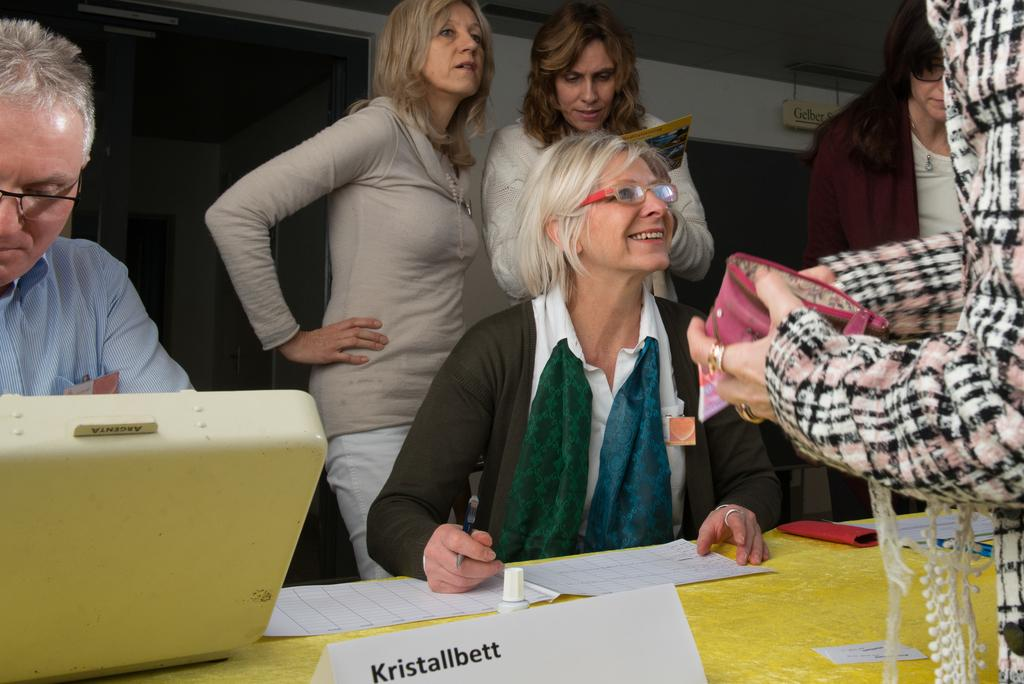How many people are in the group visible in the image? There is a group of people in the image, but the exact number cannot be determined from the provided facts. What is in front of the group of people? There is a platform in front of the group of people. What can be seen on the platform? Objects are present on the platform. What is visible in the background of the image? There is a roof and additional objects visible in the background of the image. What type of ink is being used by the group of people in the image? There is no indication in the image that the group of people is using ink, so it cannot be determined from the picture. 